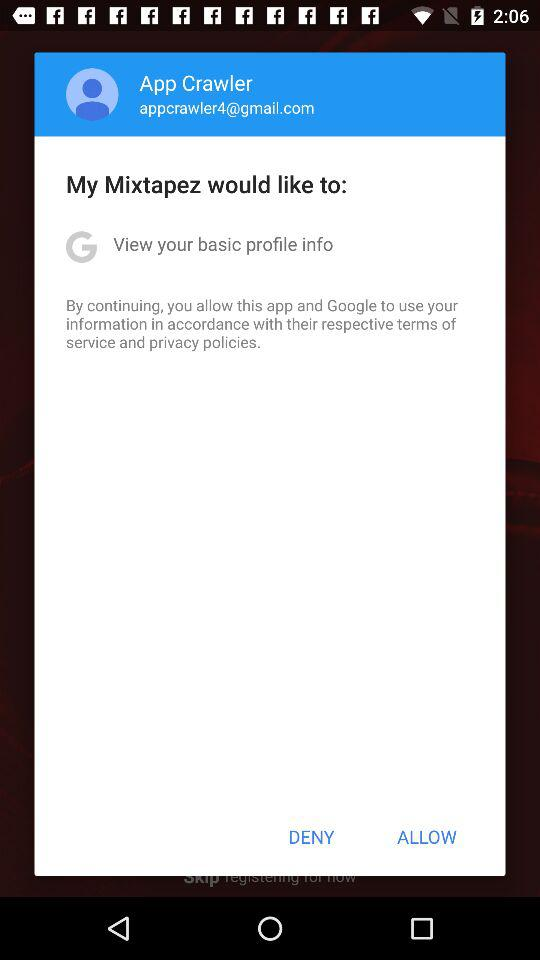What application is asking to view basic profile information? The application asking to view basic profile information is "Google". 